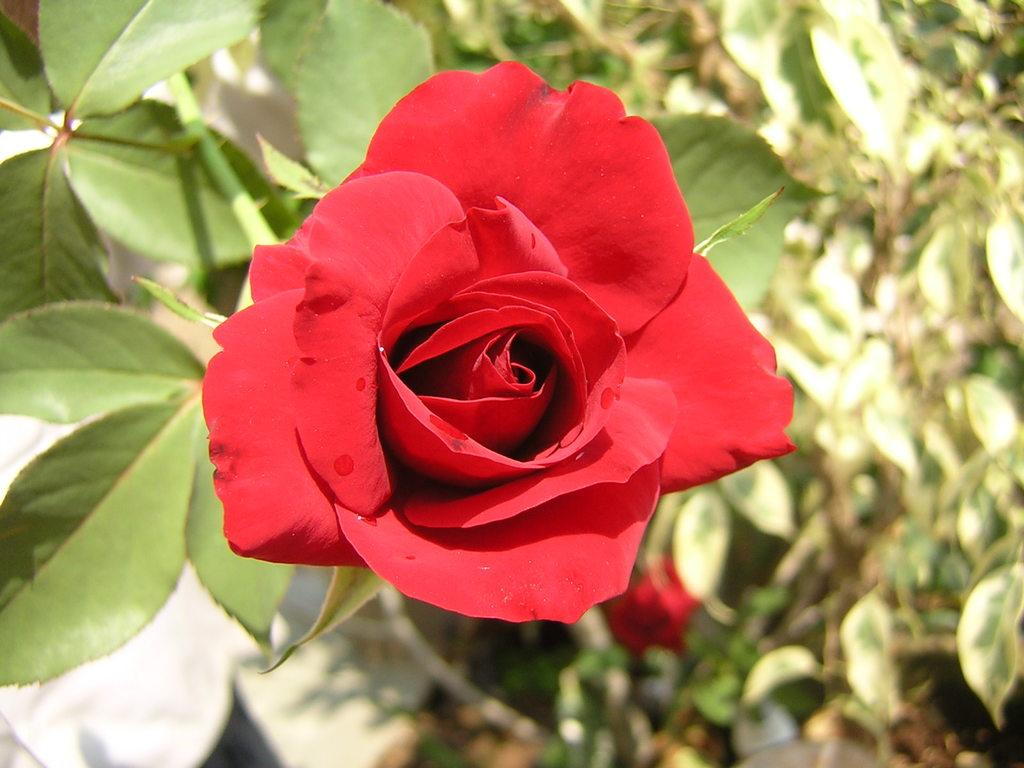What is present in the picture? There is a plant in the picture. What type of flowers are on the plant? The plant has two rose flowers on it. What type of insurance does the plant have in the image? There is no mention of insurance in the image, as it features a plant with rose flowers. What are the hobbies of the plant in the image? Plants do not have hobbies, as they are living organisms and not capable of engaging in hobbies. 